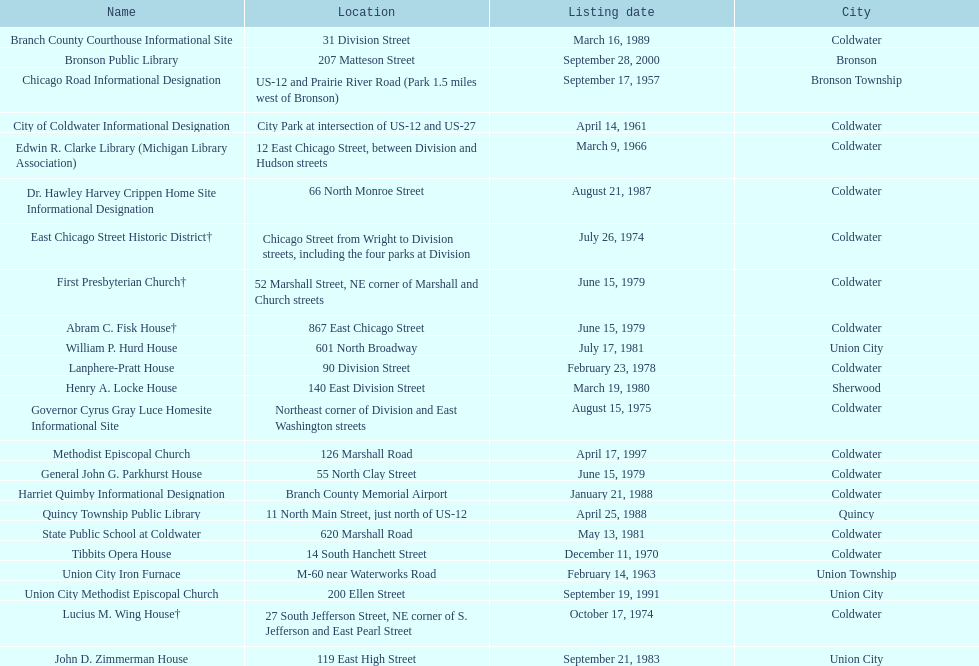How many historic sites were listed in 1988? 2. 